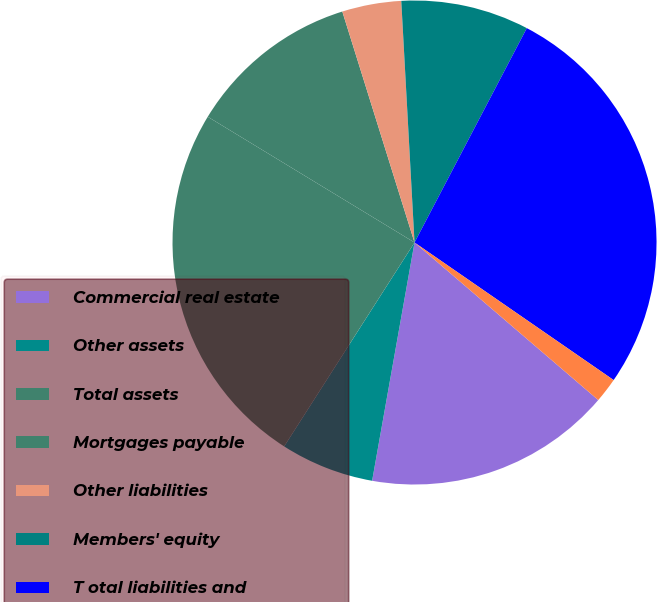Convert chart. <chart><loc_0><loc_0><loc_500><loc_500><pie_chart><fcel>Commercial real estate<fcel>Other assets<fcel>Total assets<fcel>Mortgages payable<fcel>Other liabilities<fcel>Members' equity<fcel>T otal liabilities and<fcel>Company's net investment in<nl><fcel>16.52%<fcel>6.25%<fcel>24.64%<fcel>11.48%<fcel>3.95%<fcel>8.55%<fcel>26.94%<fcel>1.66%<nl></chart> 